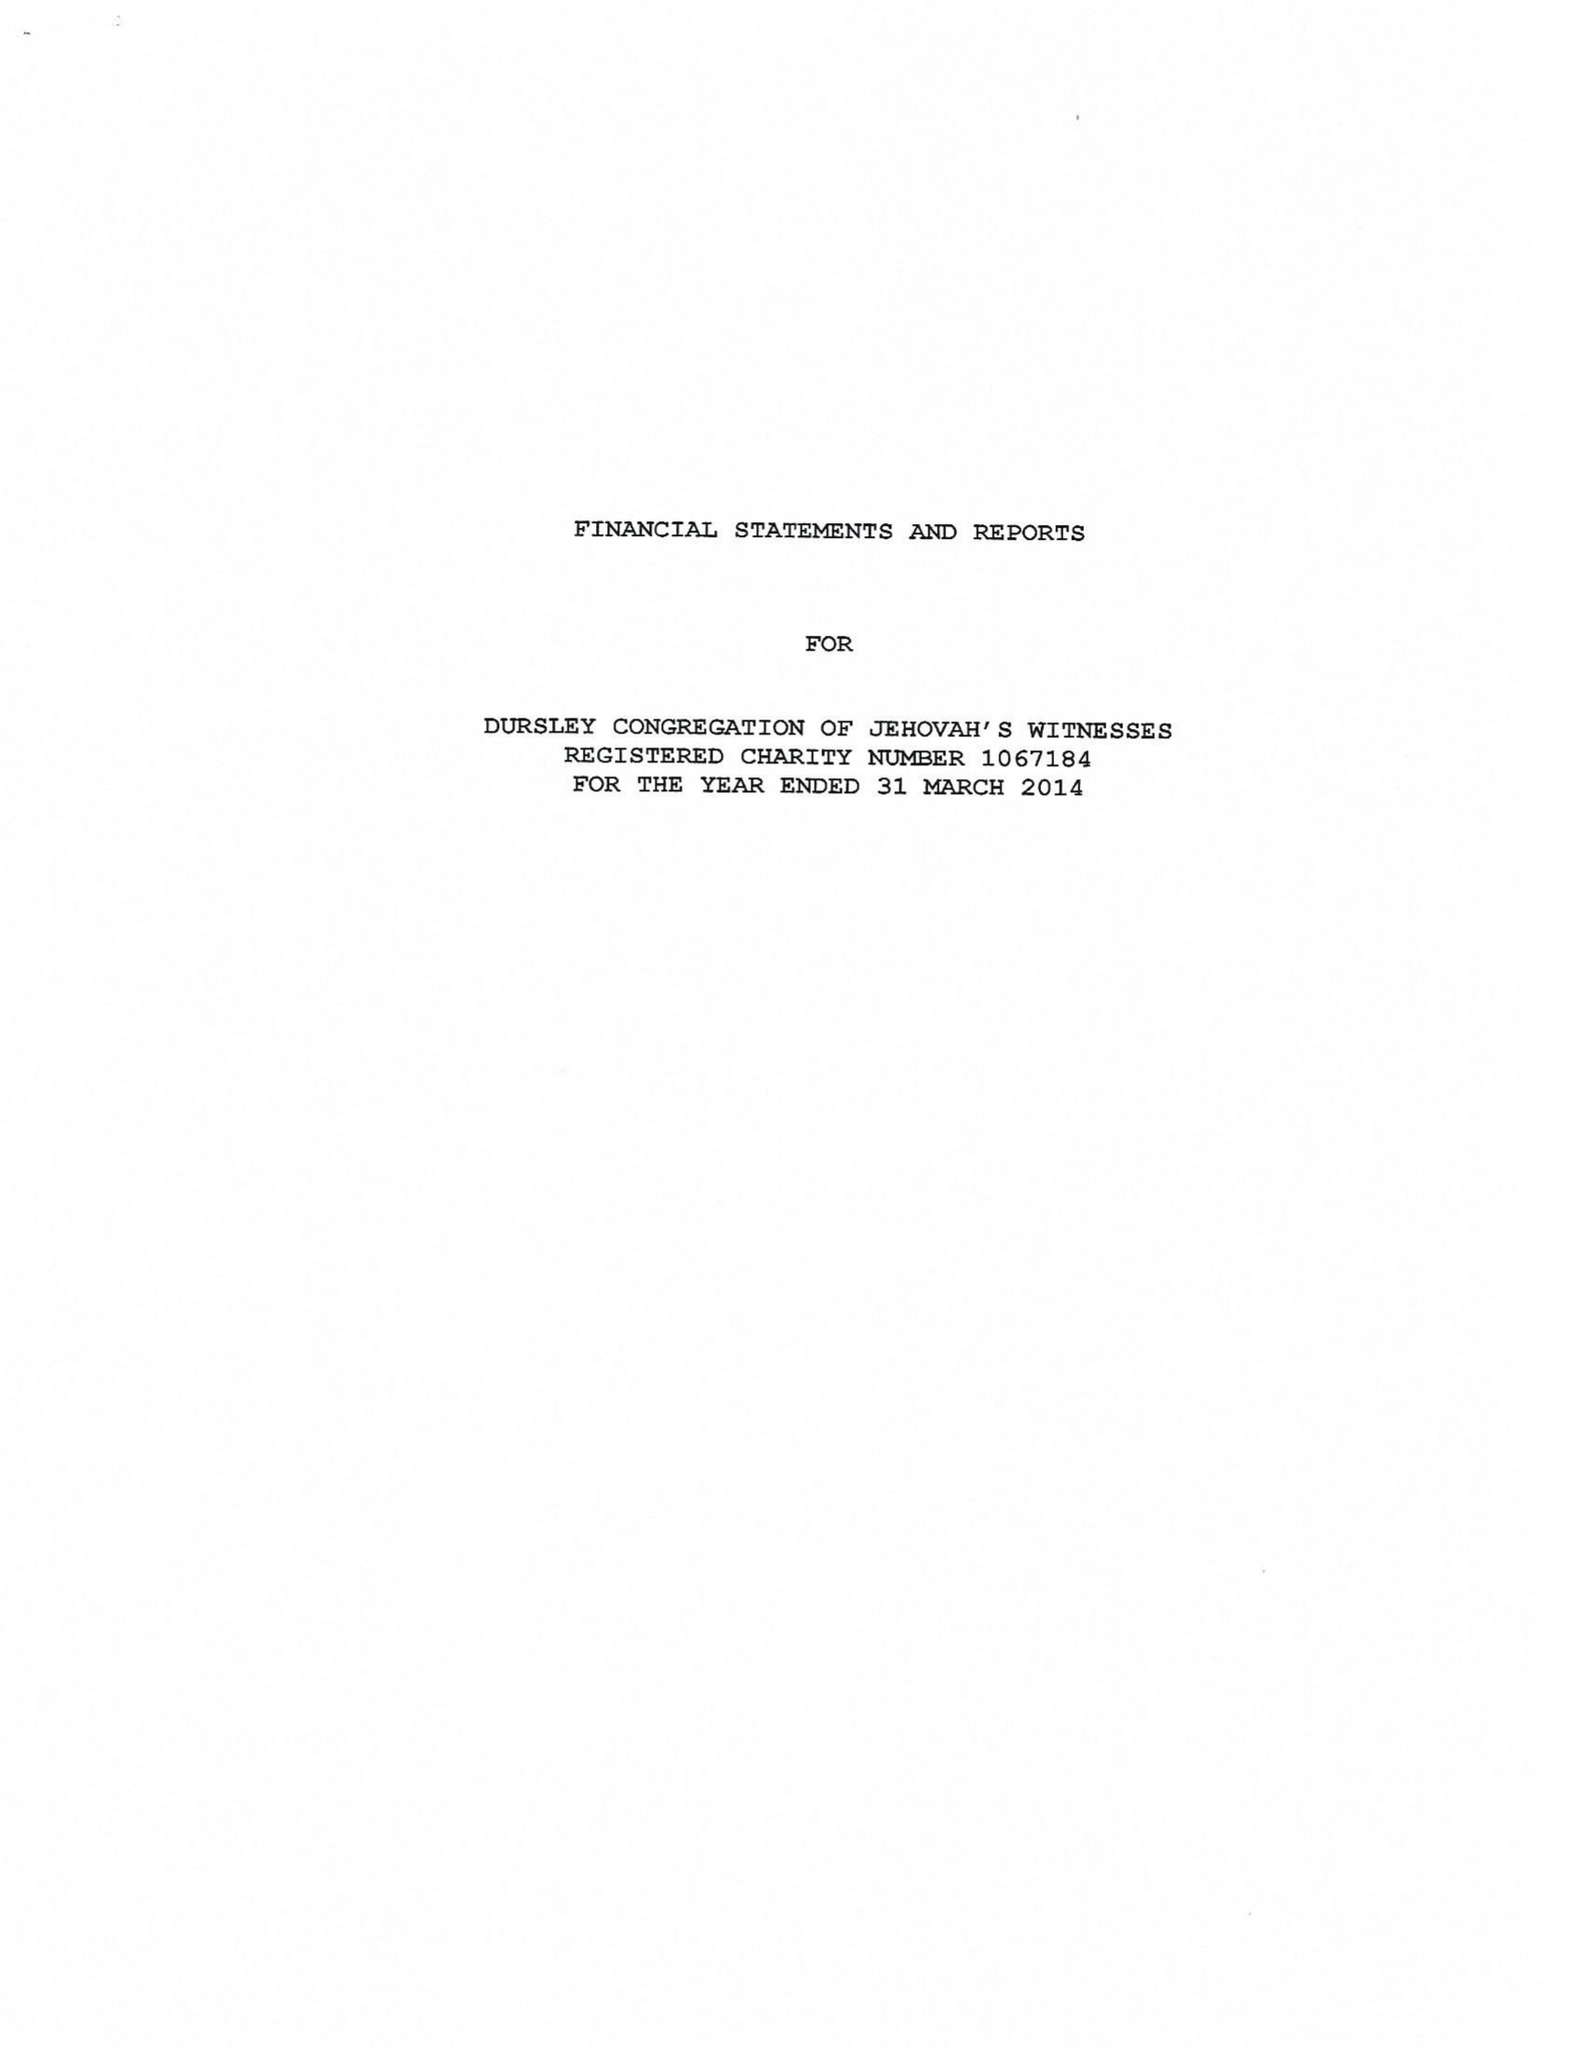What is the value for the address__street_line?
Answer the question using a single word or phrase. 54 LONG STREET 